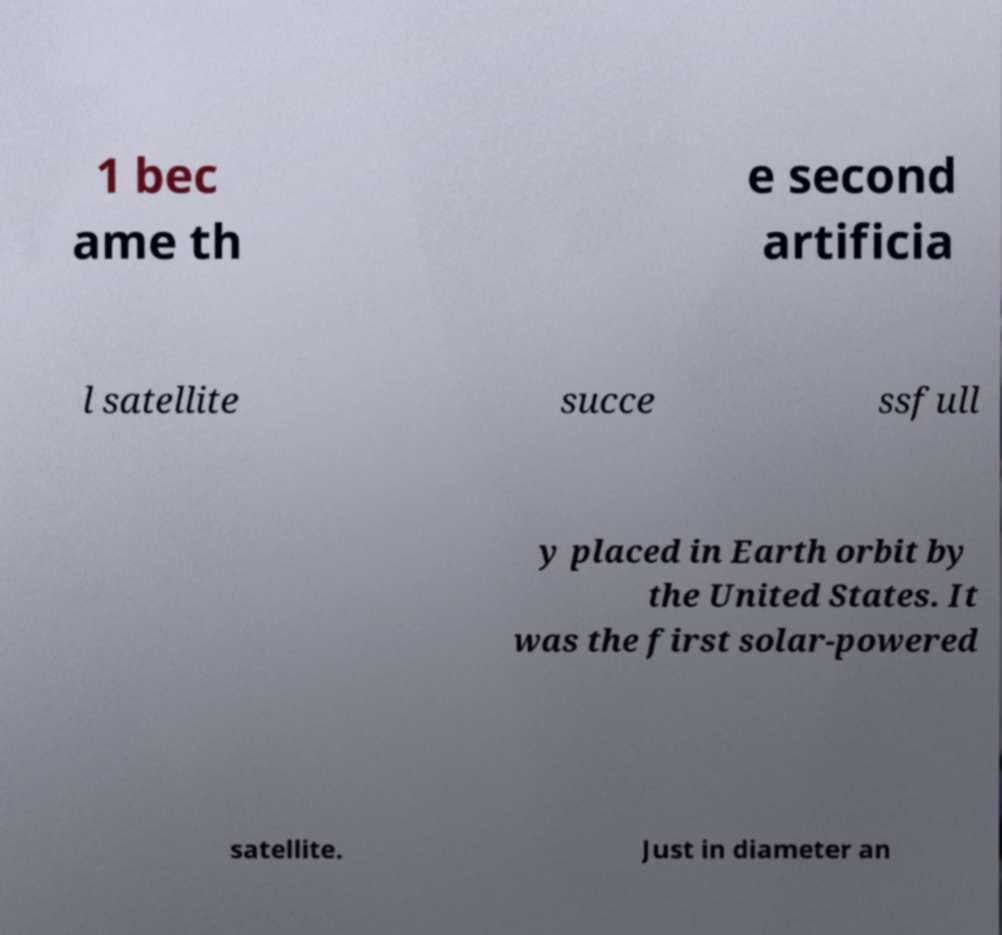Could you extract and type out the text from this image? 1 bec ame th e second artificia l satellite succe ssfull y placed in Earth orbit by the United States. It was the first solar-powered satellite. Just in diameter an 